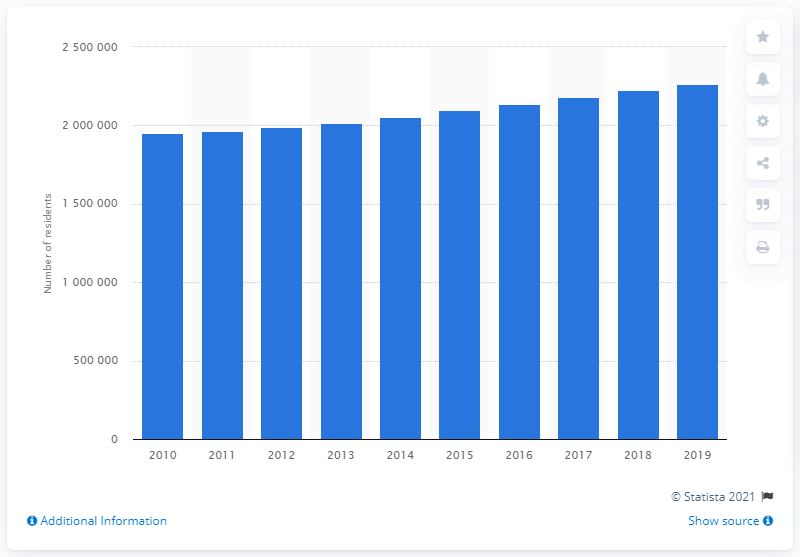Besides population growth, what other statistical metrics might this trend affect in the region? Population growth has a ripple effect on various other statistical metrics in the region. It could lead to increased demand for housing and services, affect traffic patterns, trigger construction of new infrastructure, impact school enrollments, increase job opportunities, and it may also pressure water resources in this desert region. Analyzing such metrics could provide insights into urban development and resource management challenges faced by the area. 